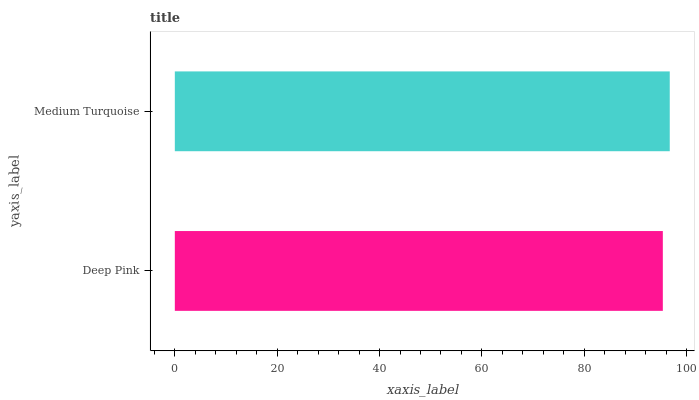Is Deep Pink the minimum?
Answer yes or no. Yes. Is Medium Turquoise the maximum?
Answer yes or no. Yes. Is Medium Turquoise the minimum?
Answer yes or no. No. Is Medium Turquoise greater than Deep Pink?
Answer yes or no. Yes. Is Deep Pink less than Medium Turquoise?
Answer yes or no. Yes. Is Deep Pink greater than Medium Turquoise?
Answer yes or no. No. Is Medium Turquoise less than Deep Pink?
Answer yes or no. No. Is Medium Turquoise the high median?
Answer yes or no. Yes. Is Deep Pink the low median?
Answer yes or no. Yes. Is Deep Pink the high median?
Answer yes or no. No. Is Medium Turquoise the low median?
Answer yes or no. No. 